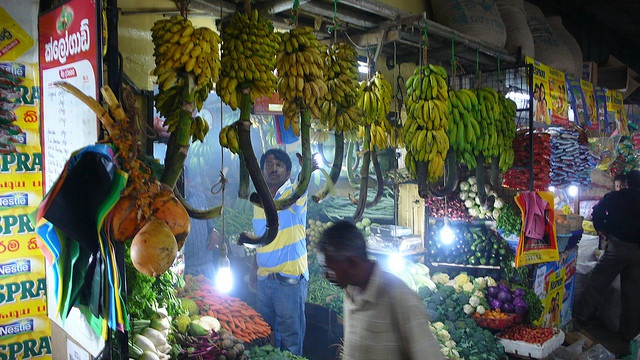Describe the objects in this image and their specific colors. I can see people in gray, black, and darkgray tones, people in gray, lightblue, darkblue, and blue tones, banana in gray, black, and olive tones, people in gray, black, navy, and purple tones, and banana in gray, black, olive, and darkgreen tones in this image. 